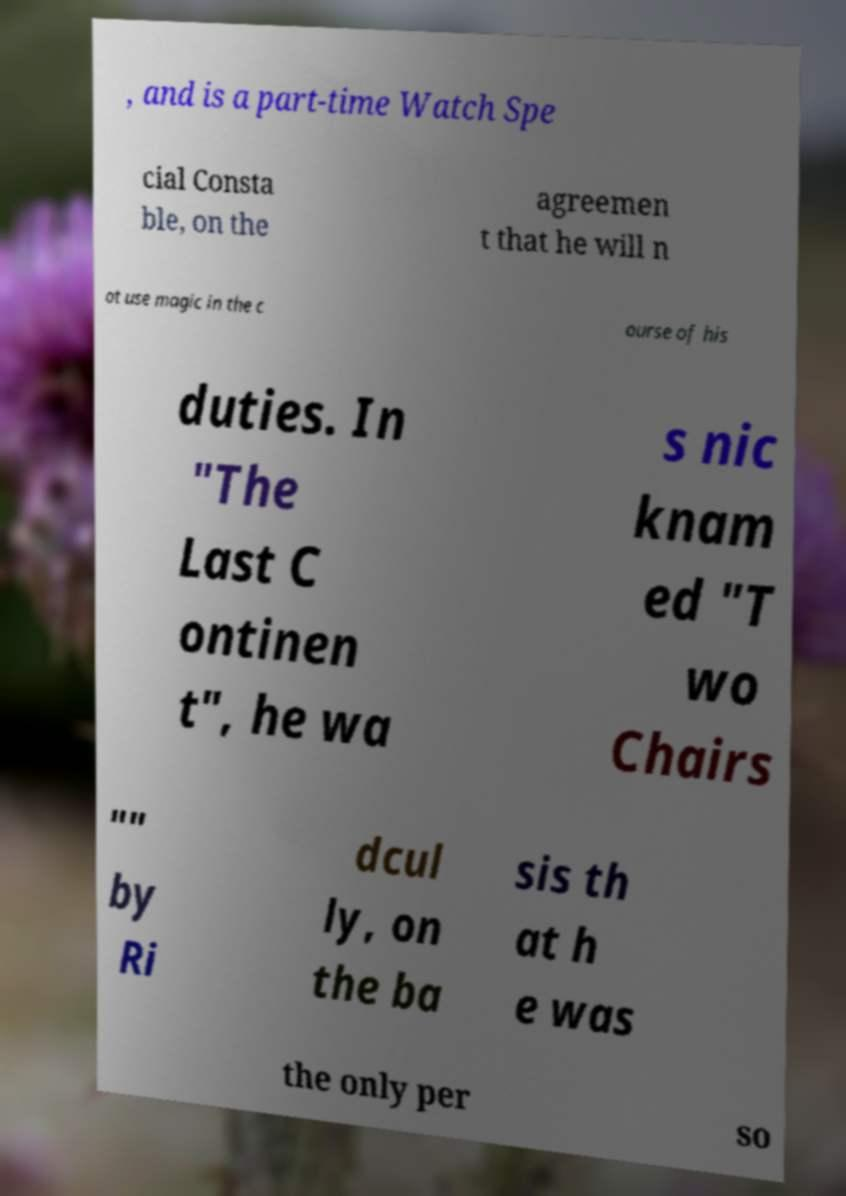There's text embedded in this image that I need extracted. Can you transcribe it verbatim? , and is a part-time Watch Spe cial Consta ble, on the agreemen t that he will n ot use magic in the c ourse of his duties. In "The Last C ontinen t", he wa s nic knam ed "T wo Chairs "" by Ri dcul ly, on the ba sis th at h e was the only per so 